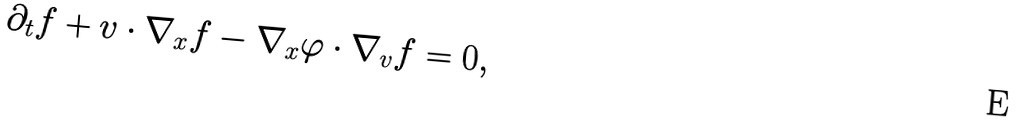<formula> <loc_0><loc_0><loc_500><loc_500>\partial _ { t } f + v \cdot \nabla _ { x } f - \nabla _ { x } \varphi \cdot \nabla _ { v } f = 0 ,</formula> 